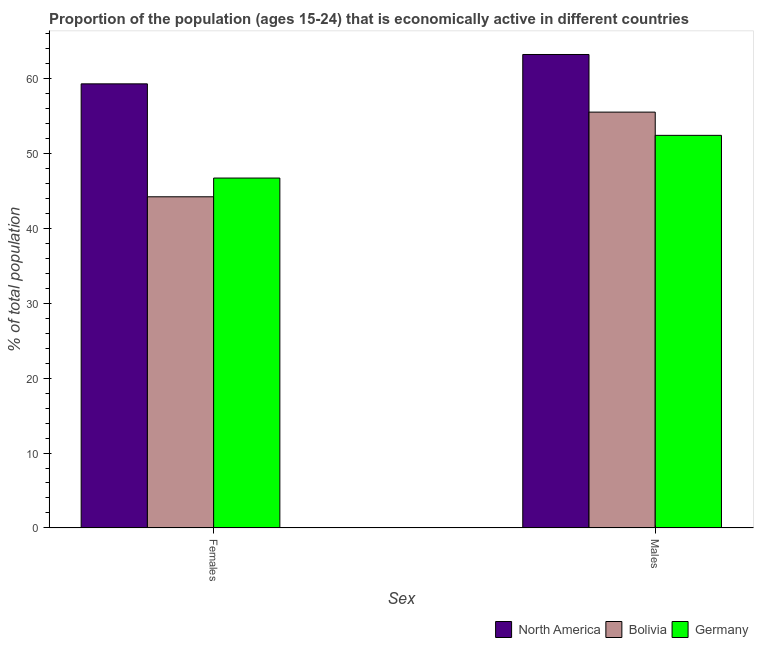How many different coloured bars are there?
Offer a terse response. 3. How many bars are there on the 2nd tick from the left?
Your answer should be compact. 3. How many bars are there on the 1st tick from the right?
Keep it short and to the point. 3. What is the label of the 1st group of bars from the left?
Give a very brief answer. Females. What is the percentage of economically active female population in North America?
Your response must be concise. 59.27. Across all countries, what is the maximum percentage of economically active male population?
Provide a succinct answer. 63.19. Across all countries, what is the minimum percentage of economically active female population?
Your answer should be very brief. 44.2. In which country was the percentage of economically active male population minimum?
Provide a short and direct response. Germany. What is the total percentage of economically active male population in the graph?
Make the answer very short. 171.09. What is the difference between the percentage of economically active female population in North America and that in Bolivia?
Your answer should be compact. 15.07. What is the difference between the percentage of economically active female population in Bolivia and the percentage of economically active male population in North America?
Offer a terse response. -18.99. What is the average percentage of economically active female population per country?
Give a very brief answer. 50.06. What is the difference between the percentage of economically active female population and percentage of economically active male population in Bolivia?
Your answer should be very brief. -11.3. In how many countries, is the percentage of economically active female population greater than 8 %?
Your response must be concise. 3. What is the ratio of the percentage of economically active female population in Germany to that in Bolivia?
Offer a very short reply. 1.06. Is the percentage of economically active female population in Germany less than that in Bolivia?
Keep it short and to the point. No. In how many countries, is the percentage of economically active female population greater than the average percentage of economically active female population taken over all countries?
Make the answer very short. 1. What does the 2nd bar from the left in Males represents?
Your response must be concise. Bolivia. What does the 3rd bar from the right in Females represents?
Offer a very short reply. North America. Are all the bars in the graph horizontal?
Your answer should be compact. No. How many countries are there in the graph?
Offer a terse response. 3. Are the values on the major ticks of Y-axis written in scientific E-notation?
Ensure brevity in your answer.  No. Does the graph contain any zero values?
Keep it short and to the point. No. Where does the legend appear in the graph?
Offer a terse response. Bottom right. How many legend labels are there?
Provide a short and direct response. 3. What is the title of the graph?
Provide a short and direct response. Proportion of the population (ages 15-24) that is economically active in different countries. Does "Tanzania" appear as one of the legend labels in the graph?
Provide a short and direct response. No. What is the label or title of the X-axis?
Offer a very short reply. Sex. What is the label or title of the Y-axis?
Your answer should be very brief. % of total population. What is the % of total population in North America in Females?
Give a very brief answer. 59.27. What is the % of total population in Bolivia in Females?
Keep it short and to the point. 44.2. What is the % of total population in Germany in Females?
Provide a succinct answer. 46.7. What is the % of total population of North America in Males?
Your answer should be compact. 63.19. What is the % of total population of Bolivia in Males?
Provide a succinct answer. 55.5. What is the % of total population in Germany in Males?
Make the answer very short. 52.4. Across all Sex, what is the maximum % of total population of North America?
Keep it short and to the point. 63.19. Across all Sex, what is the maximum % of total population in Bolivia?
Make the answer very short. 55.5. Across all Sex, what is the maximum % of total population in Germany?
Make the answer very short. 52.4. Across all Sex, what is the minimum % of total population in North America?
Offer a terse response. 59.27. Across all Sex, what is the minimum % of total population of Bolivia?
Provide a short and direct response. 44.2. Across all Sex, what is the minimum % of total population in Germany?
Your response must be concise. 46.7. What is the total % of total population in North America in the graph?
Ensure brevity in your answer.  122.46. What is the total % of total population of Bolivia in the graph?
Your answer should be very brief. 99.7. What is the total % of total population in Germany in the graph?
Your response must be concise. 99.1. What is the difference between the % of total population in North America in Females and that in Males?
Ensure brevity in your answer.  -3.92. What is the difference between the % of total population of North America in Females and the % of total population of Bolivia in Males?
Offer a terse response. 3.77. What is the difference between the % of total population of North America in Females and the % of total population of Germany in Males?
Your answer should be compact. 6.87. What is the average % of total population in North America per Sex?
Make the answer very short. 61.23. What is the average % of total population of Bolivia per Sex?
Keep it short and to the point. 49.85. What is the average % of total population in Germany per Sex?
Your answer should be compact. 49.55. What is the difference between the % of total population of North America and % of total population of Bolivia in Females?
Your answer should be very brief. 15.07. What is the difference between the % of total population in North America and % of total population in Germany in Females?
Your answer should be compact. 12.57. What is the difference between the % of total population of North America and % of total population of Bolivia in Males?
Offer a terse response. 7.69. What is the difference between the % of total population of North America and % of total population of Germany in Males?
Your response must be concise. 10.79. What is the ratio of the % of total population in North America in Females to that in Males?
Your answer should be compact. 0.94. What is the ratio of the % of total population of Bolivia in Females to that in Males?
Offer a very short reply. 0.8. What is the ratio of the % of total population of Germany in Females to that in Males?
Your response must be concise. 0.89. What is the difference between the highest and the second highest % of total population in North America?
Make the answer very short. 3.92. What is the difference between the highest and the lowest % of total population in North America?
Your response must be concise. 3.92. What is the difference between the highest and the lowest % of total population of Germany?
Offer a terse response. 5.7. 